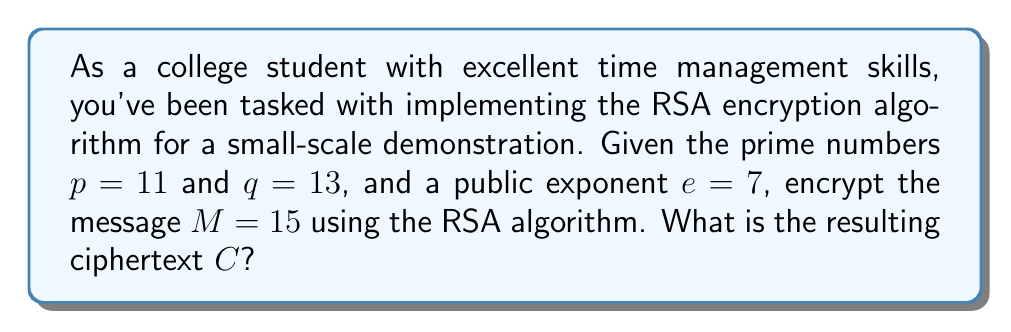Give your solution to this math problem. Let's implement the RSA encryption algorithm step by step:

1) Calculate $n = p \times q$:
   $n = 11 \times 13 = 143$

2) Calculate $\phi(n) = (p-1)(q-1)$:
   $\phi(n) = (11-1)(13-1) = 10 \times 12 = 120$

3) Check if $e$ is coprime with $\phi(n)$:
   $\gcd(7, 120) = 1$, so $e = 7$ is valid

4) The public key is $(n, e) = (143, 7)$

5) To encrypt the message $M$, we use the formula:
   $C \equiv M^e \pmod{n}$

6) Substitute the values:
   $C \equiv 15^7 \pmod{143}$

7) Calculate using modular exponentiation:
   $15^7 \pmod{143}$
   $= ((15^2 \pmod{143})^3 \times 15) \pmod{143}$
   $= ((82)^3 \times 15) \pmod{143}$
   $= (82 \times 82 \times 82 \times 15) \pmod{143}$
   $= 64 \times 82 \times 15 \pmod{143}$
   $= 78720 \pmod{143}$
   $= 106$

Therefore, the ciphertext $C = 106$.
Answer: $106$ 